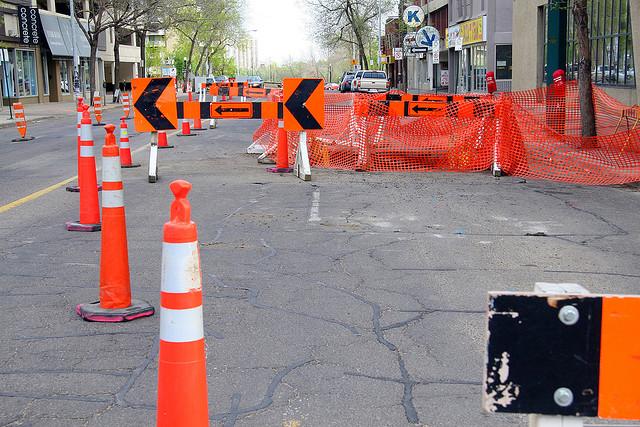Is there construction work going on?
Be succinct. Yes. Which direction are the signs pointing?
Answer briefly. Left. What letter is on the sign near the top of the picture?
Keep it brief. K. 